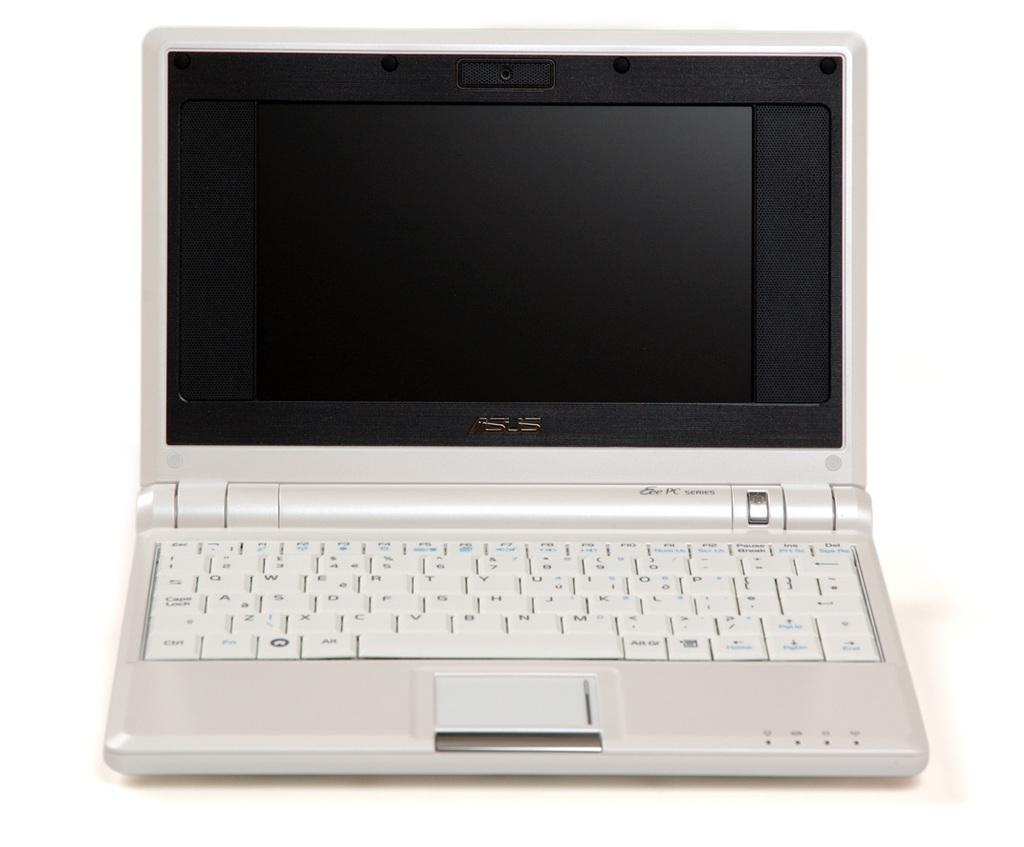What electronic device is visible in the image? There is a laptop in the image. What might the laptop be used for? The laptop could be used for various tasks, such as browsing the internet, working on documents, or streaming media. What type of maid is leading the laptop in the image? There is no maid or leading action involving the laptop in the image; it is simply a laptop sitting or placed on a surface. 